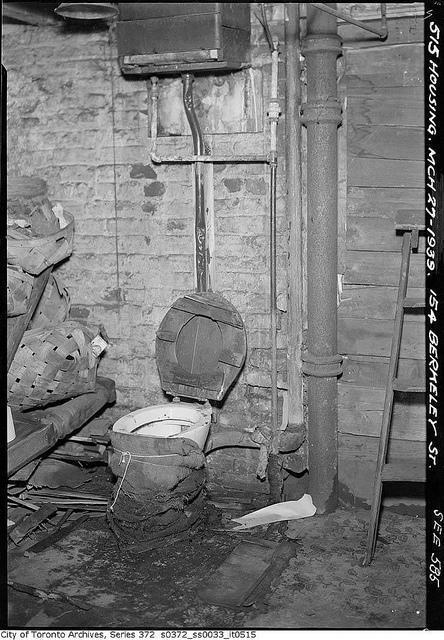How many steps are on the ladder?
Give a very brief answer. 3. How many photos in one?
Give a very brief answer. 1. How many toilets are in the picture?
Give a very brief answer. 2. How many tires on the truck are visible?
Give a very brief answer. 0. 